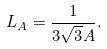Convert formula to latex. <formula><loc_0><loc_0><loc_500><loc_500>L _ { A } = \frac { 1 } { 3 \sqrt { 3 } A } .</formula> 